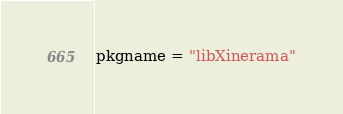<code> <loc_0><loc_0><loc_500><loc_500><_Python_>pkgname = "libXinerama"
</code> 